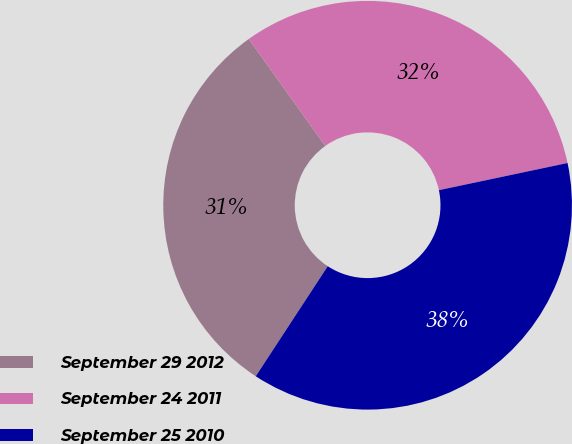Convert chart. <chart><loc_0><loc_0><loc_500><loc_500><pie_chart><fcel>September 29 2012<fcel>September 24 2011<fcel>September 25 2010<nl><fcel>30.9%<fcel>31.56%<fcel>37.53%<nl></chart> 